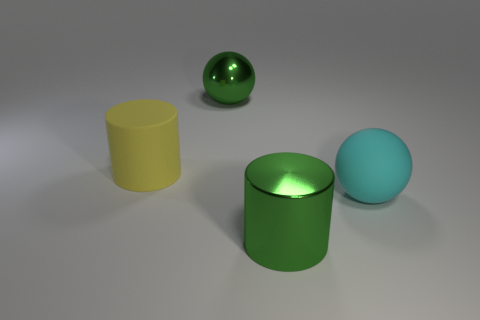There is a large ball behind the big cyan matte thing; is its color the same as the large metal cylinder?
Provide a succinct answer. Yes. What number of yellow objects are large matte spheres or rubber cylinders?
Your answer should be very brief. 1. Is the number of large objects that are on the left side of the rubber ball greater than the number of small green shiny cubes?
Your response must be concise. Yes. Is the yellow matte cylinder the same size as the green ball?
Provide a succinct answer. Yes. What color is the cylinder that is made of the same material as the cyan ball?
Ensure brevity in your answer.  Yellow. There is a thing that is the same color as the shiny cylinder; what is its shape?
Provide a short and direct response. Sphere. Is the number of cylinders to the right of the big cyan sphere the same as the number of big cylinders left of the big shiny cylinder?
Your answer should be very brief. No. What is the shape of the shiny object behind the matte thing that is in front of the yellow cylinder?
Ensure brevity in your answer.  Sphere. There is another object that is the same shape as the big cyan thing; what material is it?
Offer a very short reply. Metal. What is the color of the matte ball that is the same size as the green cylinder?
Make the answer very short. Cyan. 